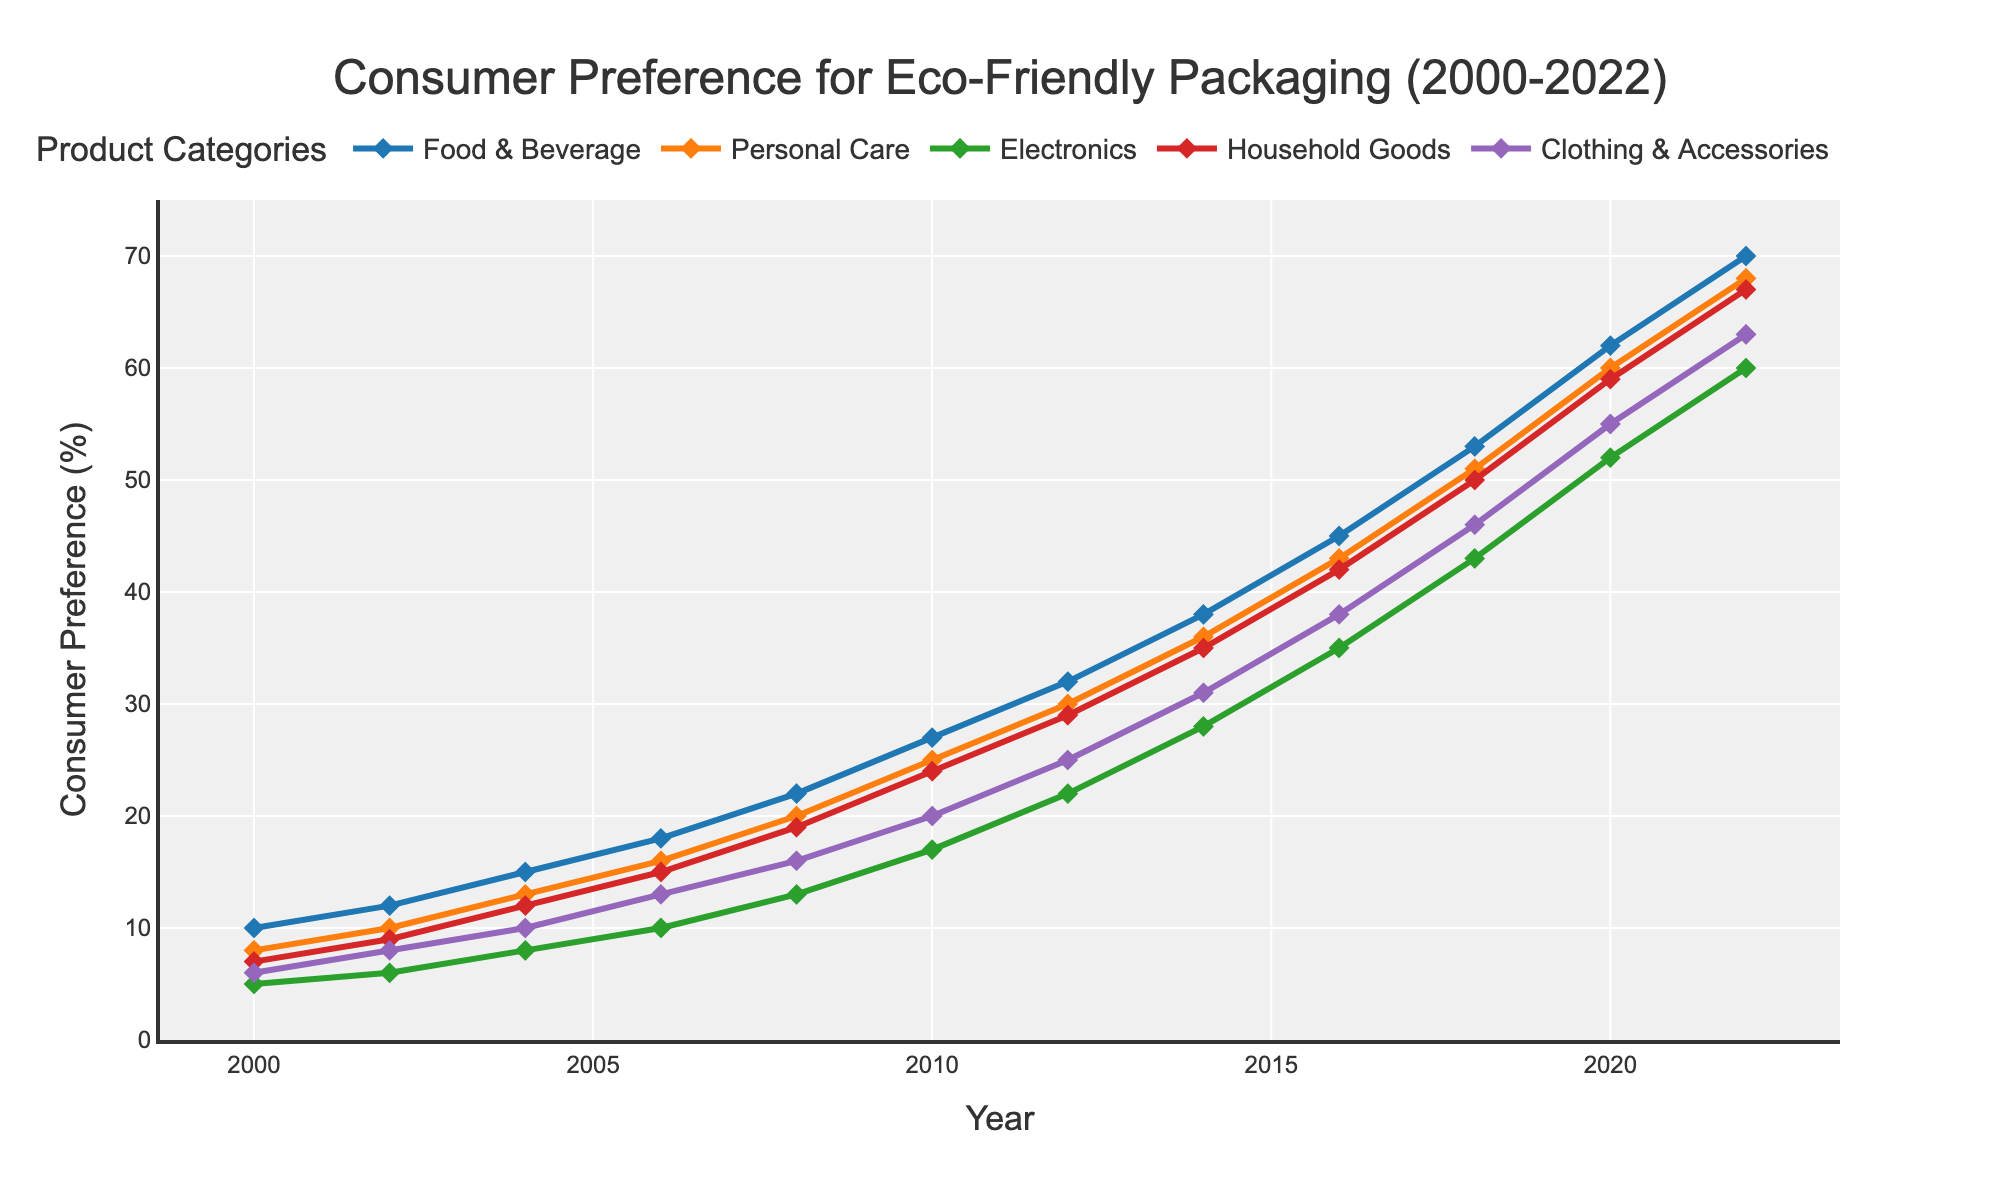How has the consumer preference for environmentally friendly packaging in the Food & Beverage category trended from 2000 to 2022? In 2000, the preference in the Food & Beverage category was 10%. It steadily increased, reaching 70% by 2022. This shows a consistent upward trend over the years.
Answer: It increased consistently Which product category had the highest consumer preference for eco-friendly packaging in 2022? By looking at the plotted data, the Food & Beverage category had the highest preference at 70% in 2022.
Answer: Food & Beverage Between which years did the Personal Care category see the largest increase in consumer preference? By comparing the increases between each data point, the largest increase for Personal Care was between 2008 and 2010, where it increased from 20% to 25%.
Answer: 2008 to 2010 How does the consumer preference for eco-friendly packaging in Household Goods compare to Electronics in 2020? In 2020, Household Goods had a preference of 59%, while Electronics had a preference of 52%. Therefore, Household Goods had a higher preference compared to Electronics.
Answer: Household Goods had higher preference What is the average consumer preference for Clothing & Accessories from 2000 to 2022? The values for Clothing & Accessories are 6, 8, 10, 13, 16, 20, 25, 31, 38, 46, 55, and 63. Summing these values gives 331. There are 12 data points, so the average is 331/12.
Answer: Approximately 27.58 Which product category showed the steepest increase in consumer preference between 2016 and 2018? By calculating the slope (change in preference) for each category, we see that Food & Beverage increased from 45% to 53%, Personal Care from 43% to 51%, Electronics from 35% to 43%, Household Goods from 42% to 50%, and Clothing & Accessories from 38% to 46%. All increases are of 8%, hence they all had equal steep increases.
Answer: All categories increased equally What is the total increase in consumer preference for eco-friendly packaging in the Electronics category from 2000 to 2022? In 2000, the preference for Electronics was 5%. In 2022, it was 60%. The total increase is 60% - 5%.
Answer: 55% Compare the trend of consumer preference in Household Goods and Clothing & Accessories from 2010 to 2016. From 2010 to 2016, Household Goods increased from 24% to 42%, an increase of 18%. Clothing & Accessories increased from 20% to 38%, also an increase of 18%. Therefore, both categories experienced equal increases.
Answer: Both had equal increases Describe the overall trend in consumer preference for eco-friendly packaging across all categories from 2000 to 2022. All categories showed an increasing trend from 2000 to 2022. Although the rate of increase varies, the general direction is upward, indicating growing consumer preference for environmentally friendly packaging over time.
Answer: Consistent increase across all categories From 2004 to 2008, which product category had the smallest increase in consumer preference for eco-friendly packaging? Comparing the increases, Food & Beverage increased from 15% to 22%, Personal Care from 13% to 20%, Electronics from 8% to 13%, Household Goods from 12% to 19%, and Clothing & Accessories from 10% to 16%. Electronics had the smallest increase of 5%.
Answer: Electronics 